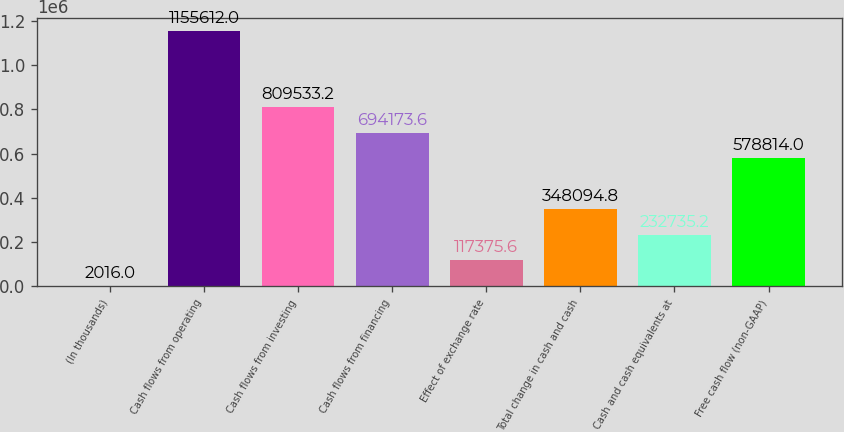<chart> <loc_0><loc_0><loc_500><loc_500><bar_chart><fcel>(In thousands)<fcel>Cash flows from operating<fcel>Cash flows from investing<fcel>Cash flows from financing<fcel>Effect of exchange rate<fcel>Total change in cash and cash<fcel>Cash and cash equivalents at<fcel>Free cash flow (non-GAAP)<nl><fcel>2016<fcel>1.15561e+06<fcel>809533<fcel>694174<fcel>117376<fcel>348095<fcel>232735<fcel>578814<nl></chart> 